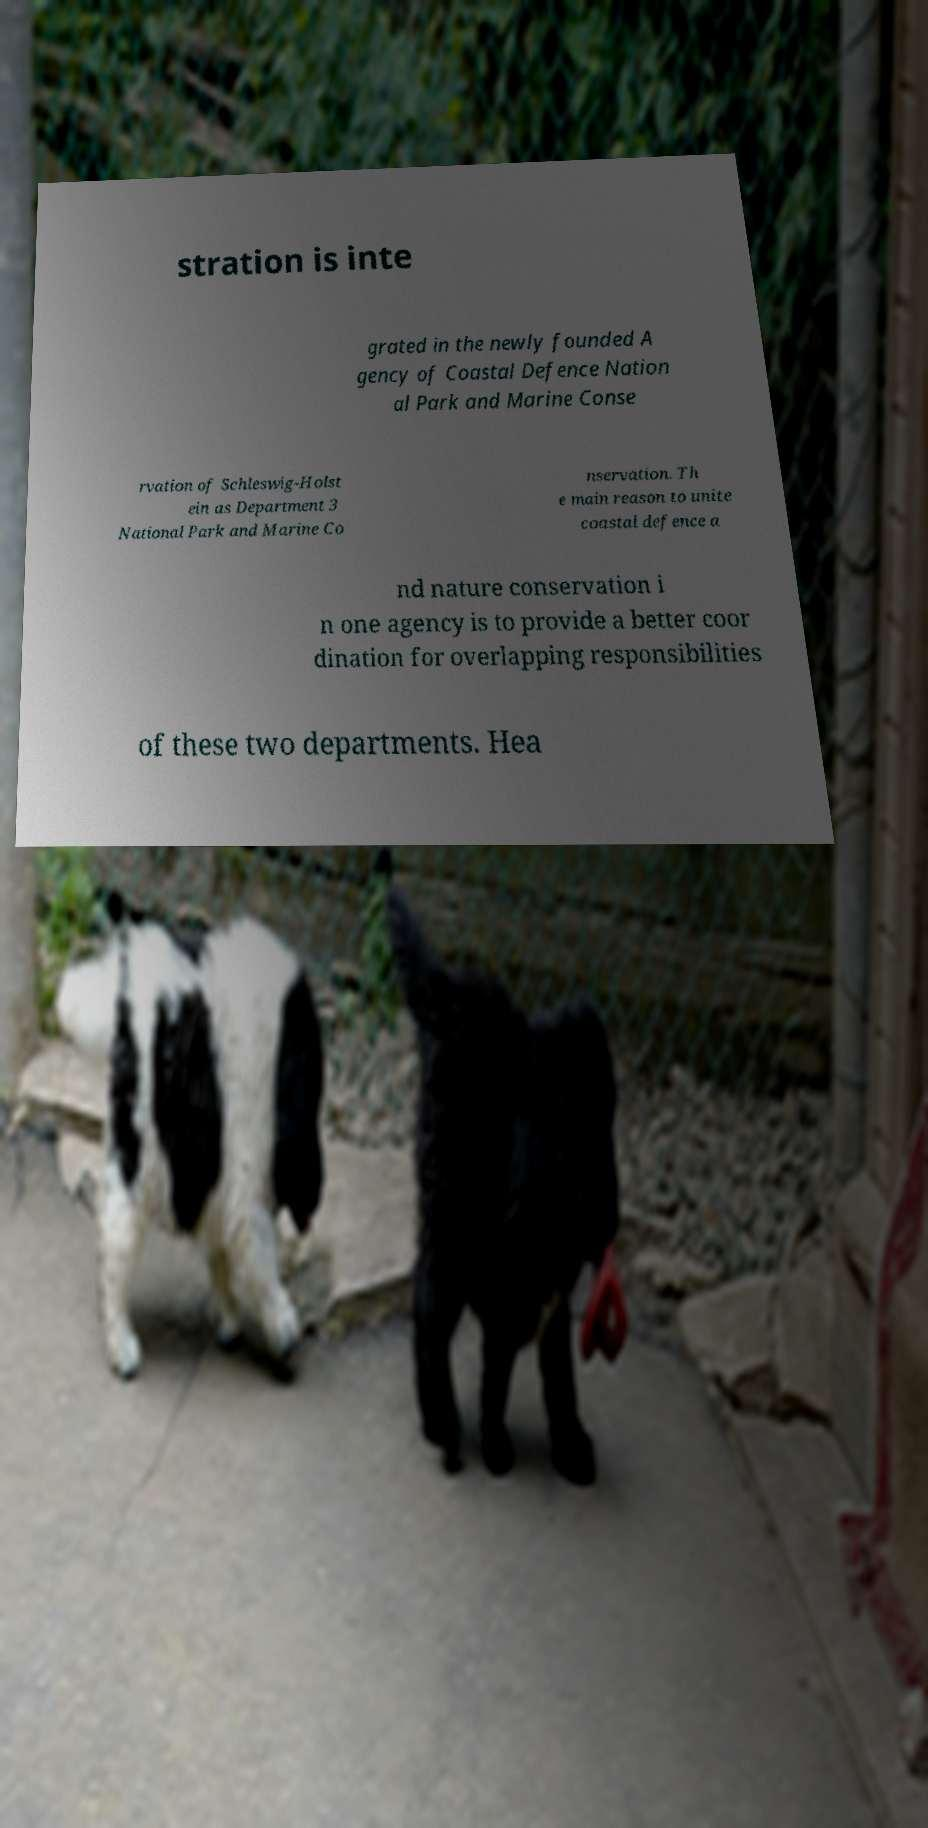Please read and relay the text visible in this image. What does it say? stration is inte grated in the newly founded A gency of Coastal Defence Nation al Park and Marine Conse rvation of Schleswig-Holst ein as Department 3 National Park and Marine Co nservation. Th e main reason to unite coastal defence a nd nature conservation i n one agency is to provide a better coor dination for overlapping responsibilities of these two departments. Hea 